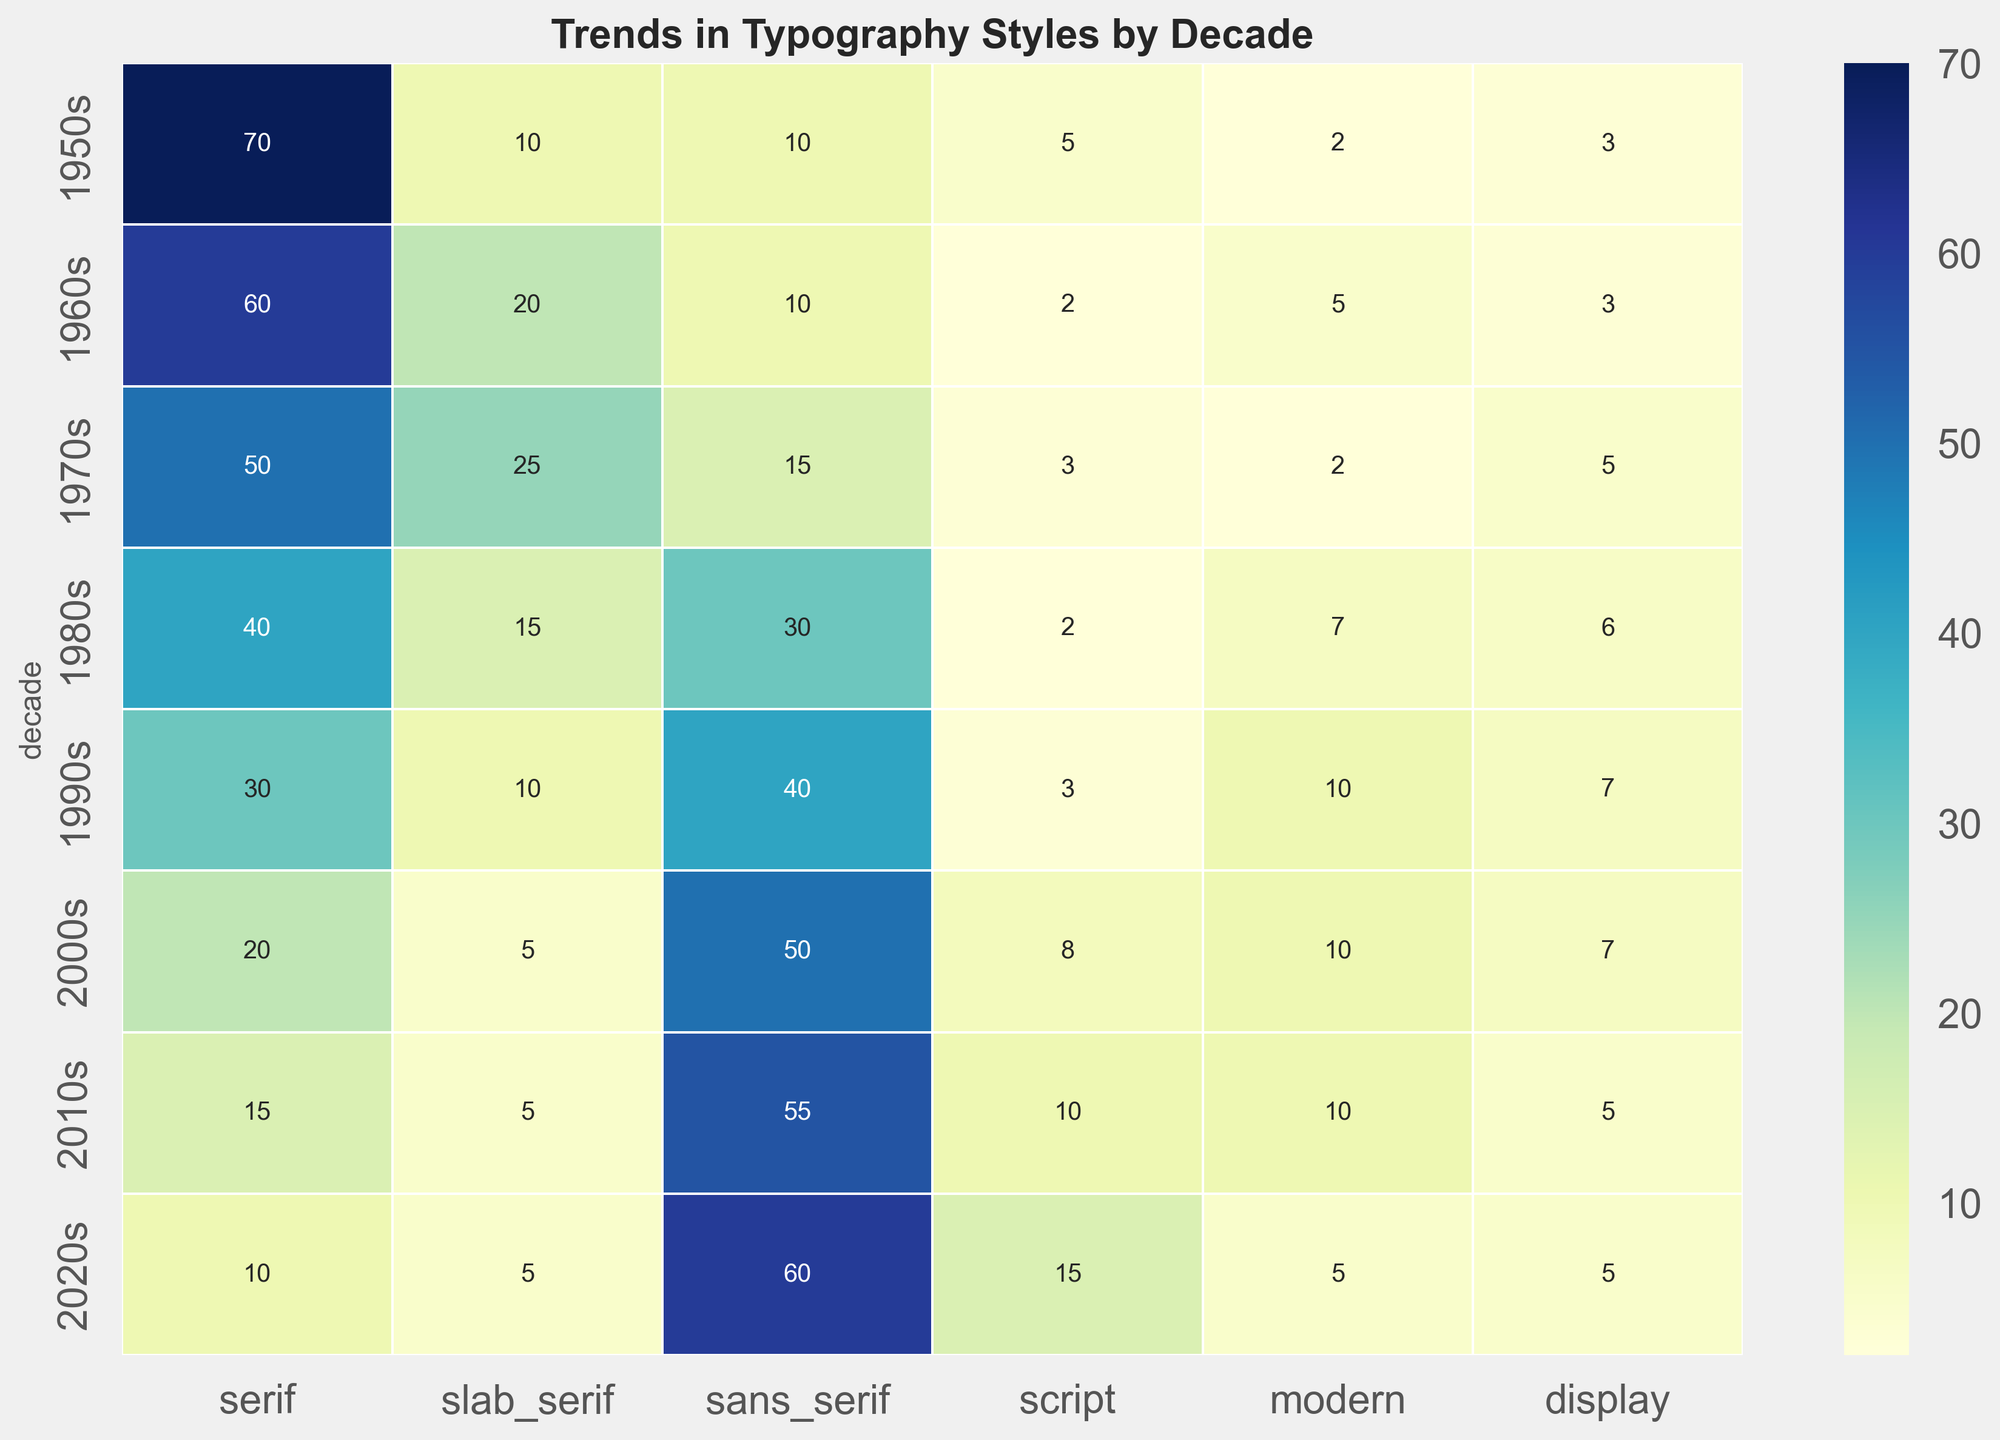What font style had the highest usage in the 2000s? By examining the heatmap, observe the values corresponding to each typography style in the row for the 2000s. The largest number will indicate the most used style.
Answer: sans_serif How did the usage of serif fonts change from the 1950s to the 2020s? Compare the values for serif fonts in the 1950s and the 2020s from the heatmap. Note the shift in values.
Answer: Decreased from 70 to 10 What is the sum of usage percentages for script and display fonts in the 1990s? Locate the 1990s row in the heatmap and add the values for script and display: 3 (script) + 7 (display).
Answer: 10 Which decade showed the highest diversity in font usage (i.e., the most evenly distributed values across all font styles)? Look for the decade where the values for different fonts are the closest to one another in magnitude.
Answer: 1980s Was the use of slab serif fonts higher in the 1970s or the 1980s? Compare the values for slab serif fonts in the rows for the 1970s (25) and the 1980s (15).
Answer: 1970s What trends can be observed in the popularity of sans serif fonts from the 1950s to the 2020s? Track the values in the sans serif column from top to bottom, noting the general increase or decrease.
Answer: Increasing trend from 10 to 60 Considering all font styles, which style had the largest increase in usage from the 1950s to the 2020s? Subtract the values for each font style in the 2020s from those in the 1950s and determine which has the highest positive change.
Answer: sans_serif (+50) What is the average usage percentage of modern fonts across all decades? Add all the values in the modern column and divide by the number of decades (8).
Answer: (2 + 5 + 2 + 7 + 10 + 10 + 10 + 5)/8 = 6.375 